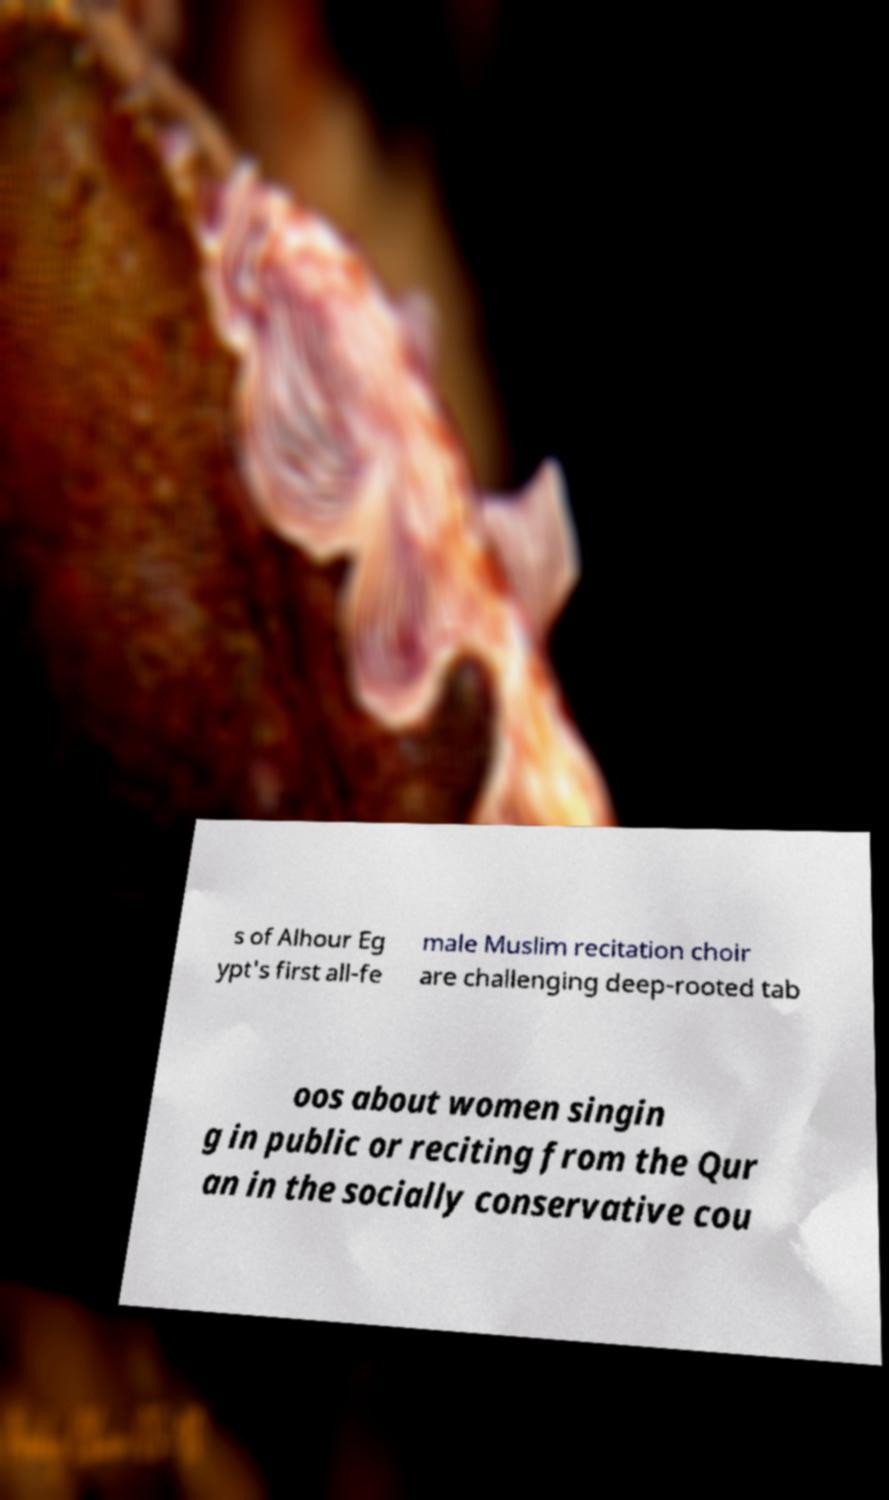Can you read and provide the text displayed in the image?This photo seems to have some interesting text. Can you extract and type it out for me? s of Alhour Eg ypt's first all-fe male Muslim recitation choir are challenging deep-rooted tab oos about women singin g in public or reciting from the Qur an in the socially conservative cou 